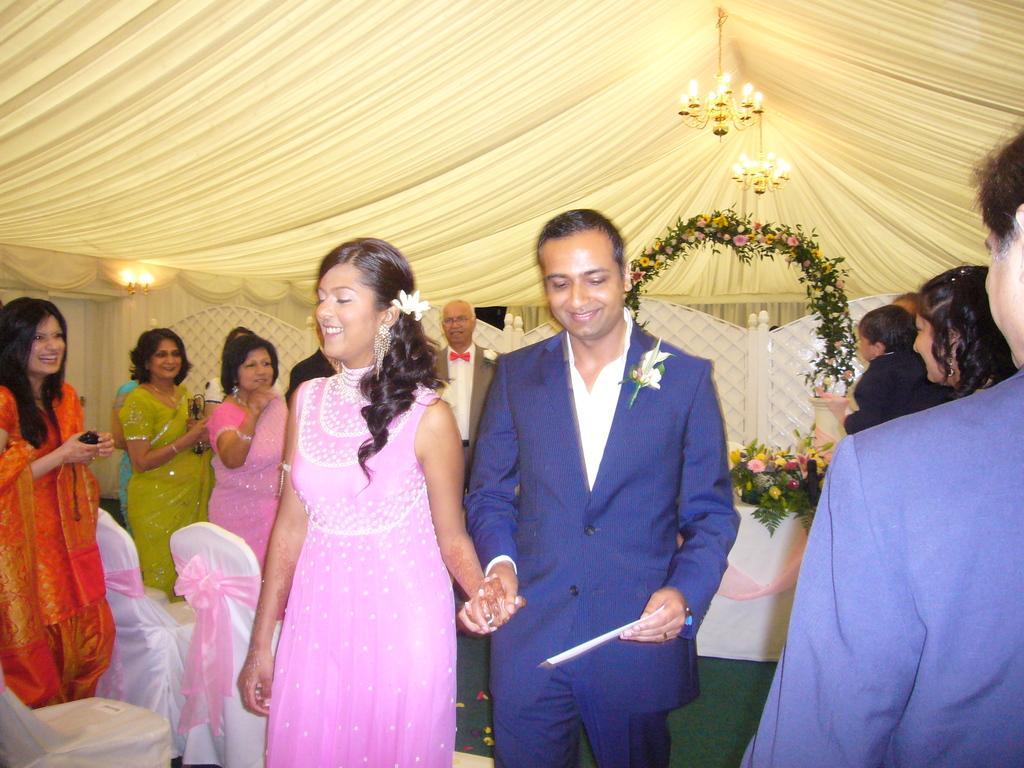Describe this image in one or two sentences. In this picture we can see a man holding an object in one hand and the hand of a woman with other hand. We can see some people standing and holding objects. There are chairs, clothes, chandeliers, a few flowers, leaves and other objects. 